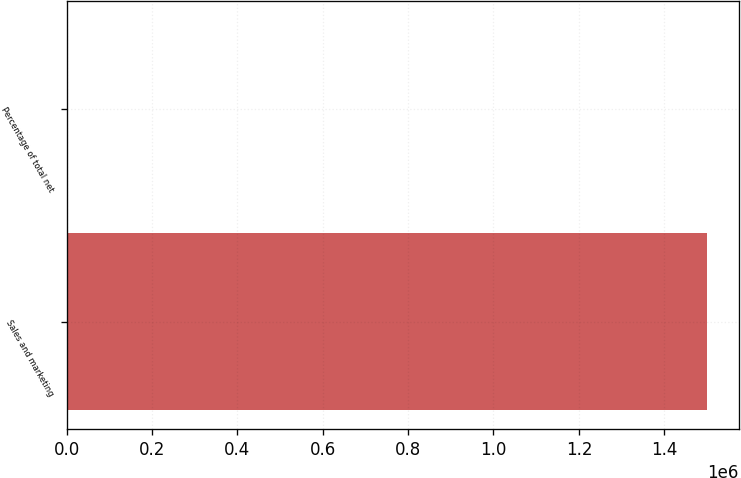Convert chart to OTSL. <chart><loc_0><loc_0><loc_500><loc_500><bar_chart><fcel>Sales and marketing<fcel>Percentage of total net<nl><fcel>1.4999e+06<fcel>36<nl></chart> 